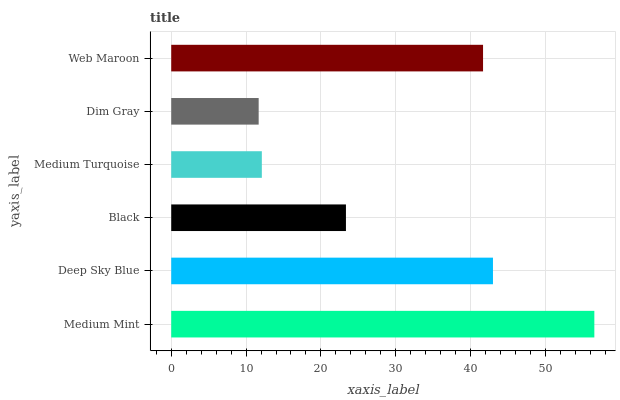Is Dim Gray the minimum?
Answer yes or no. Yes. Is Medium Mint the maximum?
Answer yes or no. Yes. Is Deep Sky Blue the minimum?
Answer yes or no. No. Is Deep Sky Blue the maximum?
Answer yes or no. No. Is Medium Mint greater than Deep Sky Blue?
Answer yes or no. Yes. Is Deep Sky Blue less than Medium Mint?
Answer yes or no. Yes. Is Deep Sky Blue greater than Medium Mint?
Answer yes or no. No. Is Medium Mint less than Deep Sky Blue?
Answer yes or no. No. Is Web Maroon the high median?
Answer yes or no. Yes. Is Black the low median?
Answer yes or no. Yes. Is Black the high median?
Answer yes or no. No. Is Dim Gray the low median?
Answer yes or no. No. 